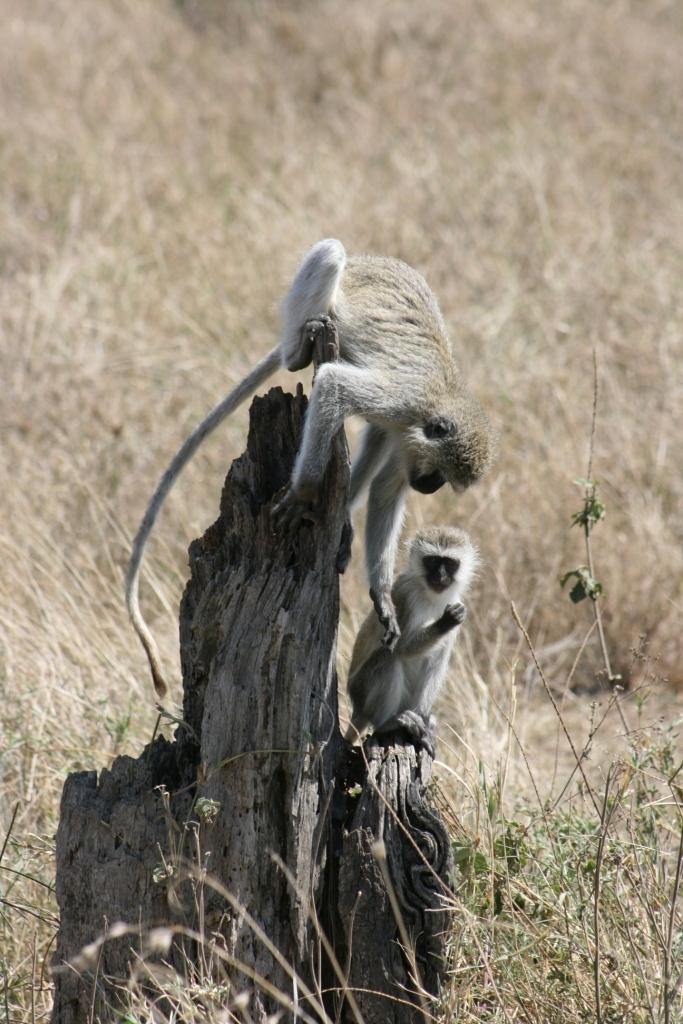What type of vegetation is at the bottom of the image? There is grass at the bottom of the image. What material is present in the middle of the image? There is some wood in the middle of the image. How many monkeys are visible in the image? There are two monkeys in the front of the image. What type of hammer can be seen in the image? There is no hammer present in the image. How does the smell of the wood affect the monkeys in the image? There is no mention of smell in the image, and the monkeys' reaction to the wood cannot be determined. 